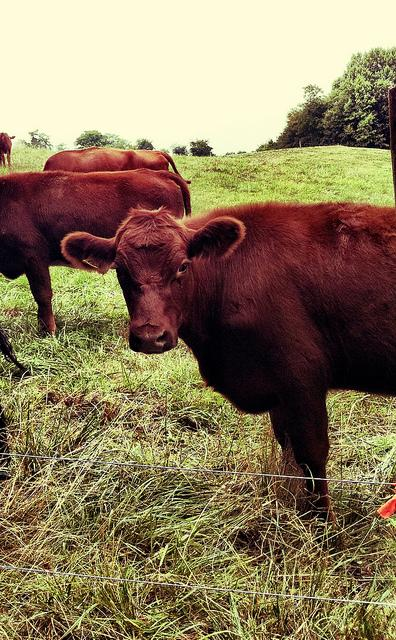What has the big ears? Please explain your reasoning. cow. The cow has big ears. 